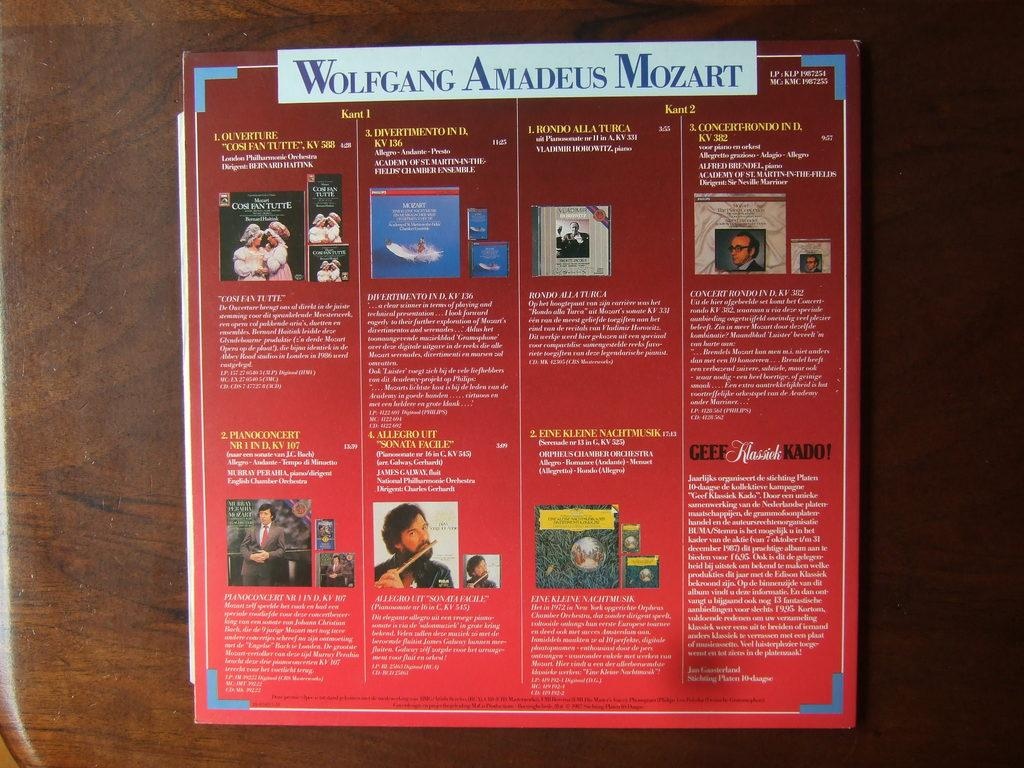<image>
Relay a brief, clear account of the picture shown. An informational poster that says Wolfgang Amadeus Mozart at the top. 